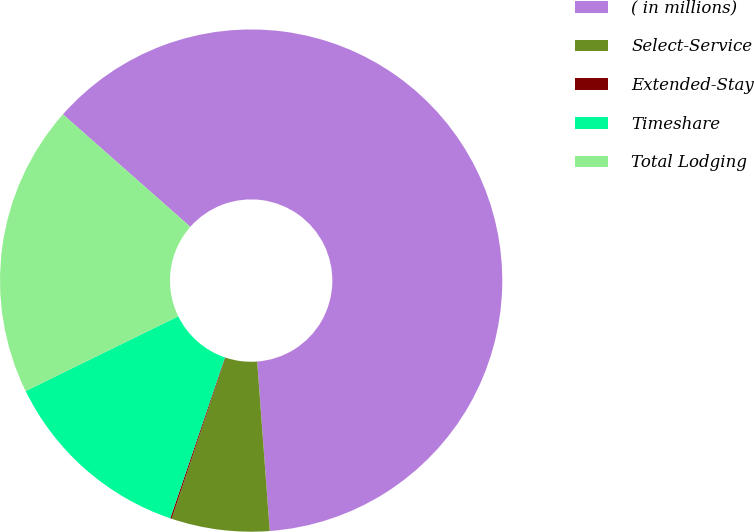Convert chart to OTSL. <chart><loc_0><loc_0><loc_500><loc_500><pie_chart><fcel>( in millions)<fcel>Select-Service<fcel>Extended-Stay<fcel>Timeshare<fcel>Total Lodging<nl><fcel>62.3%<fcel>6.31%<fcel>0.09%<fcel>12.53%<fcel>18.76%<nl></chart> 